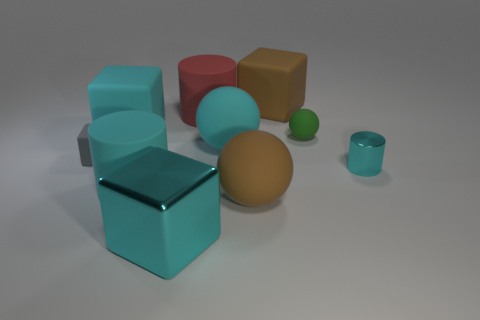There is a matte cylinder to the left of the red rubber cylinder; is it the same color as the tiny object that is in front of the gray rubber object?
Provide a short and direct response. Yes. Are there any large cyan blocks to the right of the brown cube?
Ensure brevity in your answer.  No. There is a cyan thing that is in front of the cyan rubber sphere and right of the big cyan metallic cube; what material is it?
Keep it short and to the point. Metal. Does the cyan object that is right of the brown matte block have the same material as the gray block?
Offer a terse response. No. What is the small cyan object made of?
Your response must be concise. Metal. What is the size of the cyan metallic object that is to the right of the large brown ball?
Your answer should be very brief. Small. Are there any other things that are the same color as the small metallic cylinder?
Keep it short and to the point. Yes. There is a cyan cylinder on the right side of the cyan matte thing that is in front of the cyan rubber ball; is there a cyan metal thing to the left of it?
Offer a terse response. Yes. Does the big rubber cube to the right of the big cyan cylinder have the same color as the big metallic block?
Offer a very short reply. No. How many cylinders are large green matte objects or brown rubber objects?
Keep it short and to the point. 0. 